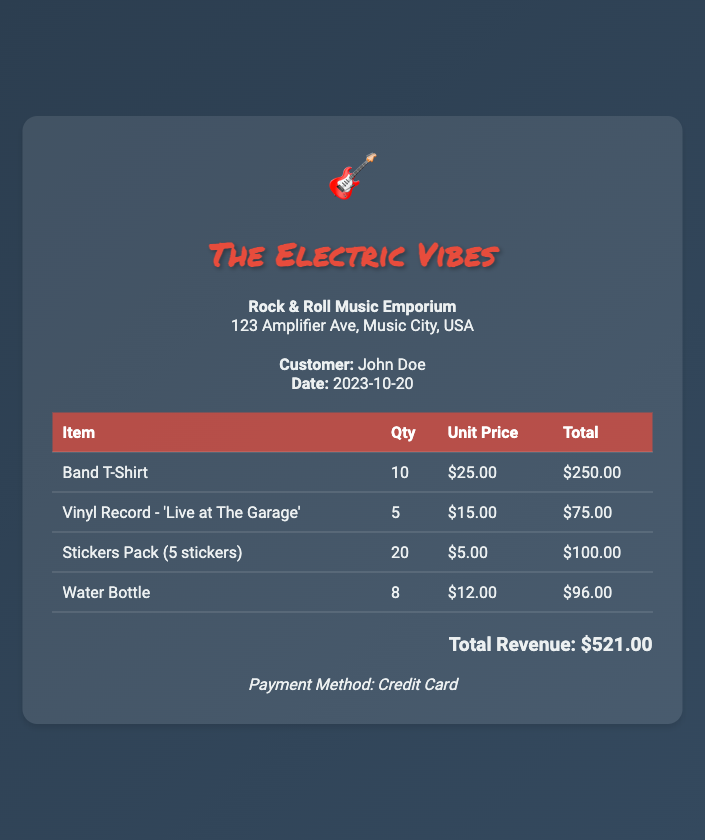what is the customer's name? The document states the customer's name as John Doe.
Answer: John Doe what is the date of the transaction? The date listed on the receipt is 2023-10-20.
Answer: 2023-10-20 how many Band T-Shirts were purchased? The receipt shows a quantity of 10 Band T-Shirts were bought.
Answer: 10 what is the unit price of the Vinyl Record? The unit price for the Vinyl Record is mentioned as $15.00.
Answer: $15.00 what is the total revenue generated from all items? The document provides a total revenue of $521.00 from all items sold.
Answer: $521.00 how many stickers were sold in total? The document states that 20 stickers packs, each containing 5 stickers, were sold.
Answer: 100 what payment method was used? The payment method noted in the document is Credit Card.
Answer: Credit Card which item generated the highest revenue? The highest revenue generating item is the Band T-Shirt with a total of $250.00.
Answer: Band T-Shirt what is the store's name? The store's name is Rock & Roll Music Emporium as listed on the receipt.
Answer: Rock & Roll Music Emporium 